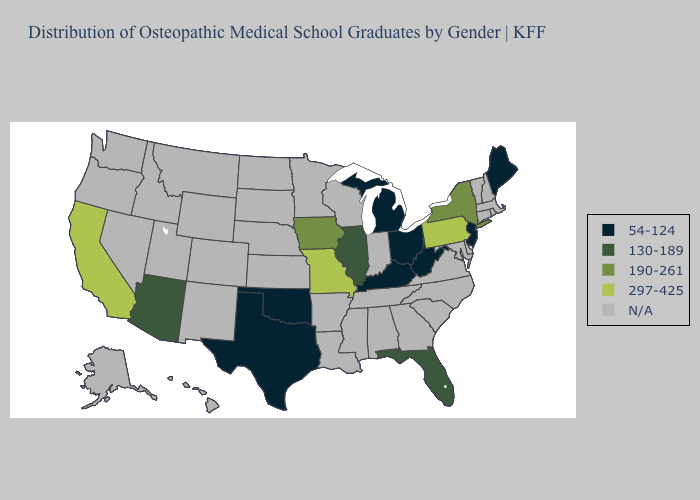What is the value of Mississippi?
Give a very brief answer. N/A. Does Arizona have the lowest value in the West?
Write a very short answer. Yes. Does Pennsylvania have the lowest value in the Northeast?
Give a very brief answer. No. Among the states that border Oklahoma , does Missouri have the lowest value?
Short answer required. No. Name the states that have a value in the range 130-189?
Write a very short answer. Arizona, Florida, Illinois. Name the states that have a value in the range 190-261?
Short answer required. Iowa, New York. What is the value of Alaska?
Concise answer only. N/A. What is the highest value in the West ?
Answer briefly. 297-425. What is the value of Wyoming?
Write a very short answer. N/A. What is the value of New York?
Answer briefly. 190-261. Which states have the lowest value in the West?
Keep it brief. Arizona. What is the lowest value in the West?
Be succinct. 130-189. What is the highest value in the West ?
Concise answer only. 297-425. What is the highest value in states that border California?
Short answer required. 130-189. Is the legend a continuous bar?
Answer briefly. No. 